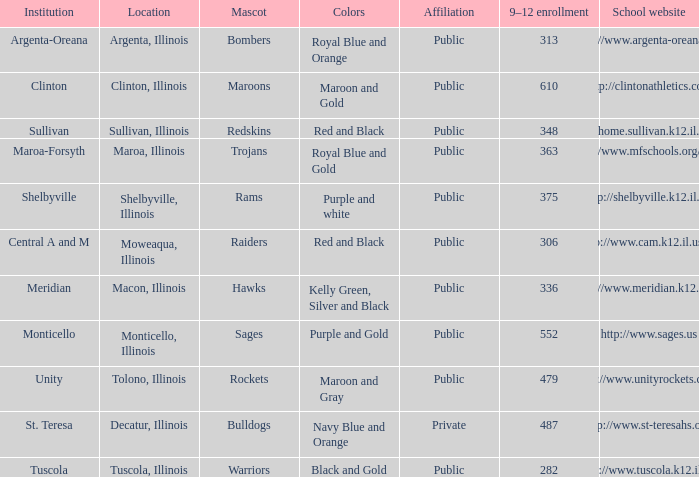What's the name of the city or town of the school that operates the http://www.mfschools.org/high/ website? Maroa-Forsyth. 